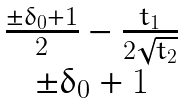Convert formula to latex. <formula><loc_0><loc_0><loc_500><loc_500>\begin{matrix} \frac { \pm \delta _ { 0 } + 1 } { 2 } - \frac { t _ { 1 } } { 2 \sqrt { t _ { 2 } } } \\ \pm \delta _ { 0 } + 1 \end{matrix}</formula> 